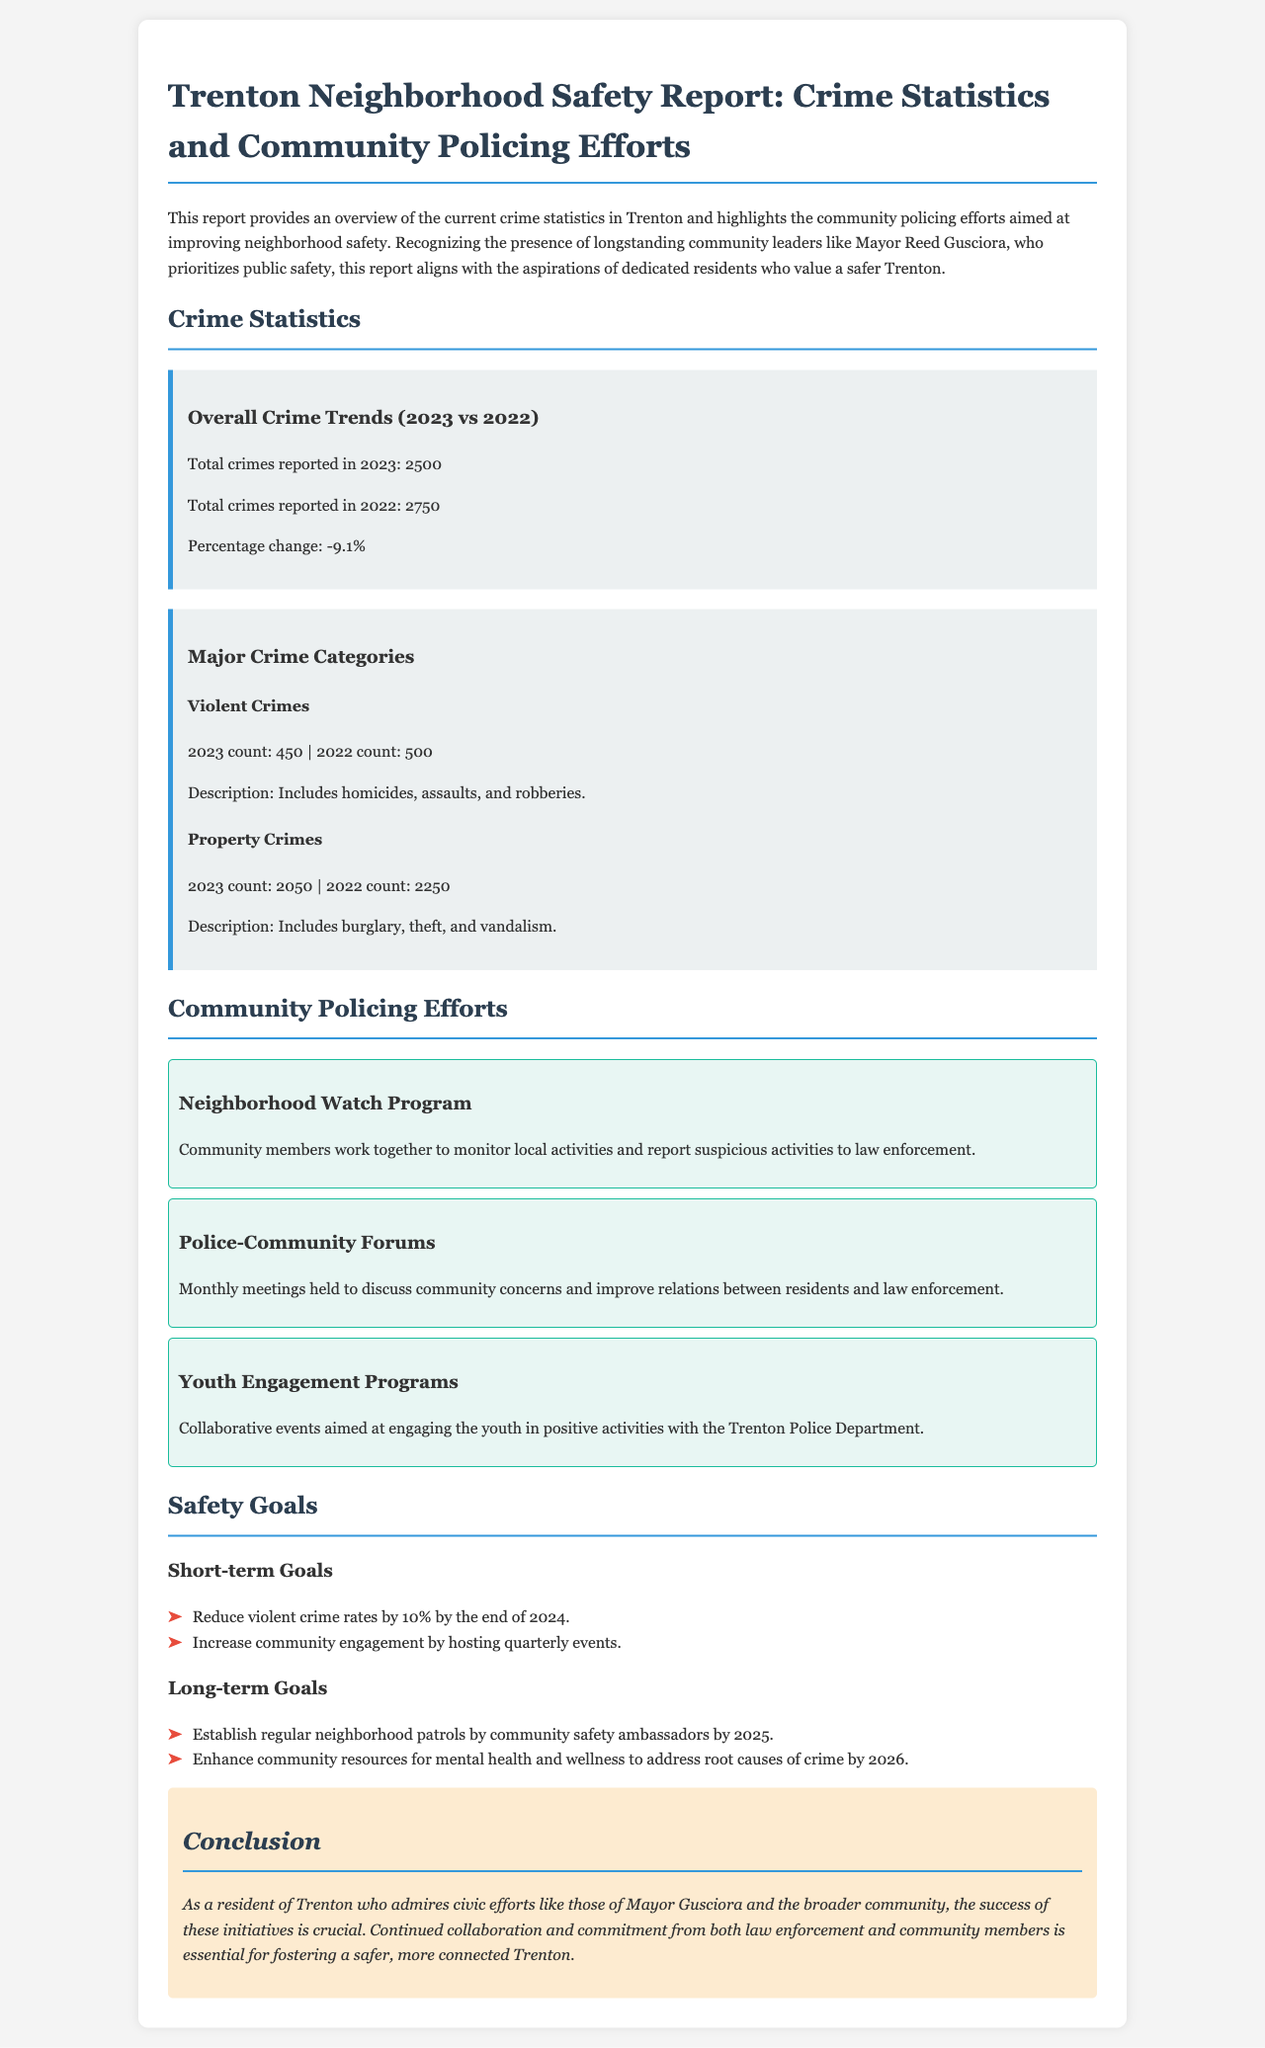What was the total number of crimes reported in 2023? The total number of crimes reported in 2023 is stated in the crime statistics section of the document.
Answer: 2500 What is the percentage change in total crimes from 2022 to 2023? The percentage change is calculated based on the total crimes reported in both years, found in the overall crime trends section.
Answer: -9.1% How many violent crimes were reported in 2023? The document outlines the specific count of violent crimes in the crime category section.
Answer: 450 What community policing initiative focuses on engaging the youth? The document lists various community policing efforts and highlights a specific initiative aimed at youth engagement.
Answer: Youth Engagement Programs By what percentage does the report aim to reduce violent crime rates by the end of 2024? The short-term safety goals section specifies the target for reducing violent crime rates.
Answer: 10% What is one of the long-term goals mentioned in the report? The report provides a list of long-term goals for improving neighborhood safety, requiring synthesis from that section.
Answer: Establish regular neighborhood patrols How often are the police-community forums held? The document describes the frequency of the meetings aimed at improving community relations with law enforcement.
Answer: Monthly Who prioritizes public safety in Trenton, according to the report? The introductory paragraph mentions a specific community leader concerned with public safety.
Answer: Mayor Reed Gusciora 